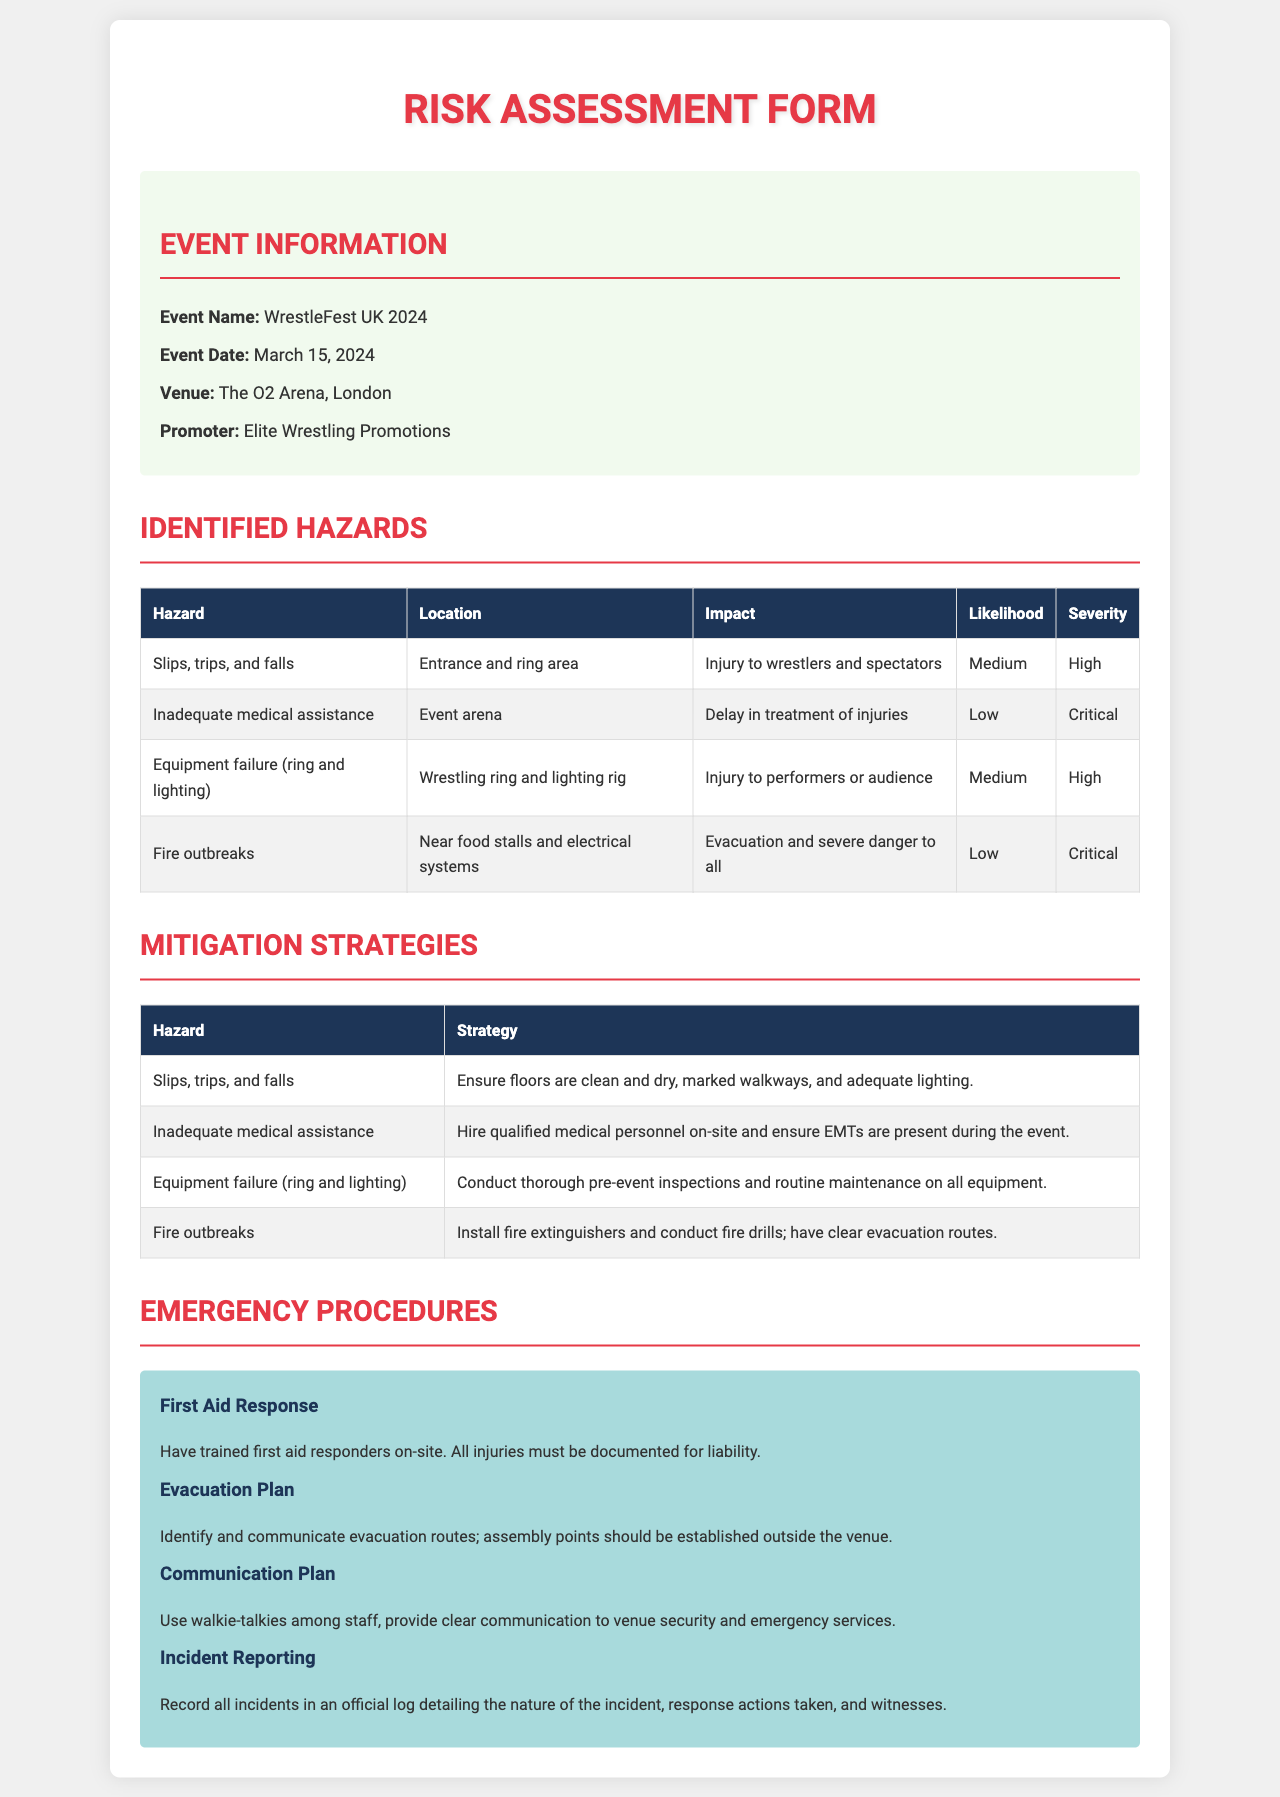what is the event name? The event name is specified in the event information section of the document.
Answer: WrestleFest UK 2024 what is the event date? The event date is listed along with other event details.
Answer: March 15, 2024 where is the event venue? The venue information is provided in the event information section.
Answer: The O2 Arena, London what is the likelihood of slips, trips, and falls? The likelihood of this hazard is noted in the identified hazards table.
Answer: Medium what mitigation strategy is used for fire outbreaks? The document outlines specific strategies for each identified hazard, including fire outbreaks.
Answer: Install fire extinguishers and conduct fire drills; have clear evacuation routes what is the impact of inadequate medical assistance? This impact is described in the identified hazards table.
Answer: Delay in treatment of injuries how many hazards are identified in the table? The number of hazards is determined by counting the entries in the identified hazards section.
Answer: 4 what type of response is specified for first aid? The type of response is outlined in the emergency procedures section of the document.
Answer: Trained first aid responders on-site what does the evacuation plan require? The details about the evacuation plan are specified in the emergency procedures section.
Answer: Identify and communicate evacuation routes what should be recorded in the incident reporting? The document specifies what information should be included in the incident reporting.
Answer: All incidents in an official log detailing the nature of the incident, response actions taken, and witnesses 